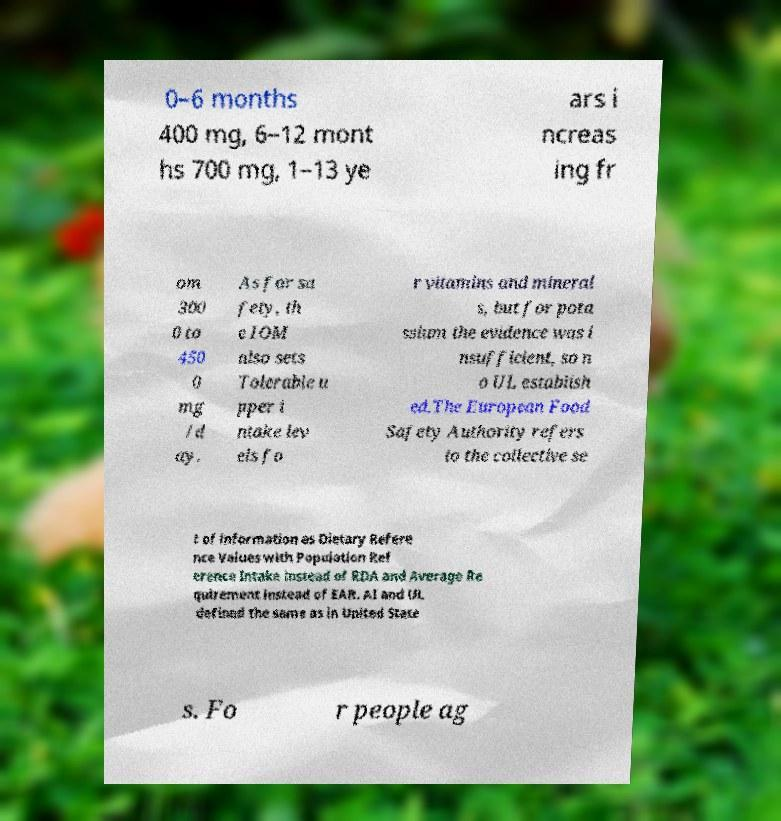Could you extract and type out the text from this image? 0–6 months 400 mg, 6–12 mont hs 700 mg, 1–13 ye ars i ncreas ing fr om 300 0 to 450 0 mg /d ay. As for sa fety, th e IOM also sets Tolerable u pper i ntake lev els fo r vitamins and mineral s, but for pota ssium the evidence was i nsufficient, so n o UL establish ed.The European Food Safety Authority refers to the collective se t of information as Dietary Refere nce Values with Population Ref erence Intake instead of RDA and Average Re quirement instead of EAR. AI and UL defined the same as in United State s. Fo r people ag 